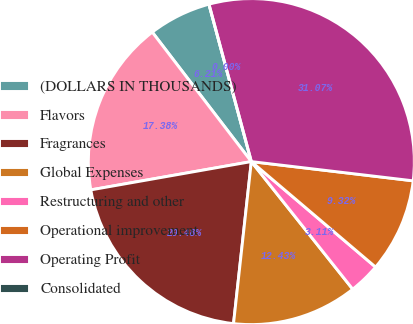Convert chart to OTSL. <chart><loc_0><loc_0><loc_500><loc_500><pie_chart><fcel>(DOLLARS IN THOUSANDS)<fcel>Flavors<fcel>Fragrances<fcel>Global Expenses<fcel>Restructuring and other<fcel>Operational improvement<fcel>Operating Profit<fcel>Consolidated<nl><fcel>6.21%<fcel>17.38%<fcel>20.48%<fcel>12.43%<fcel>3.11%<fcel>9.32%<fcel>31.07%<fcel>0.0%<nl></chart> 